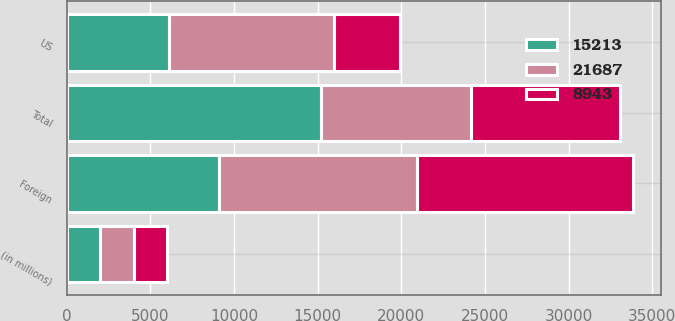<chart> <loc_0><loc_0><loc_500><loc_500><stacked_bar_chart><ecel><fcel>(in millions)<fcel>US<fcel>Foreign<fcel>Total<nl><fcel>8943<fcel>2007<fcel>3957<fcel>12900<fcel>8943<nl><fcel>21687<fcel>2006<fcel>9862<fcel>11825<fcel>8943<nl><fcel>15213<fcel>2005<fcel>6103<fcel>9110<fcel>15213<nl></chart> 